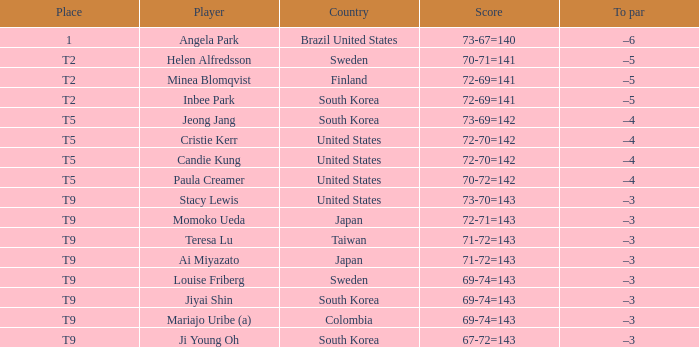Who placed t5 and had a score of 70-72=142? Paula Creamer. 